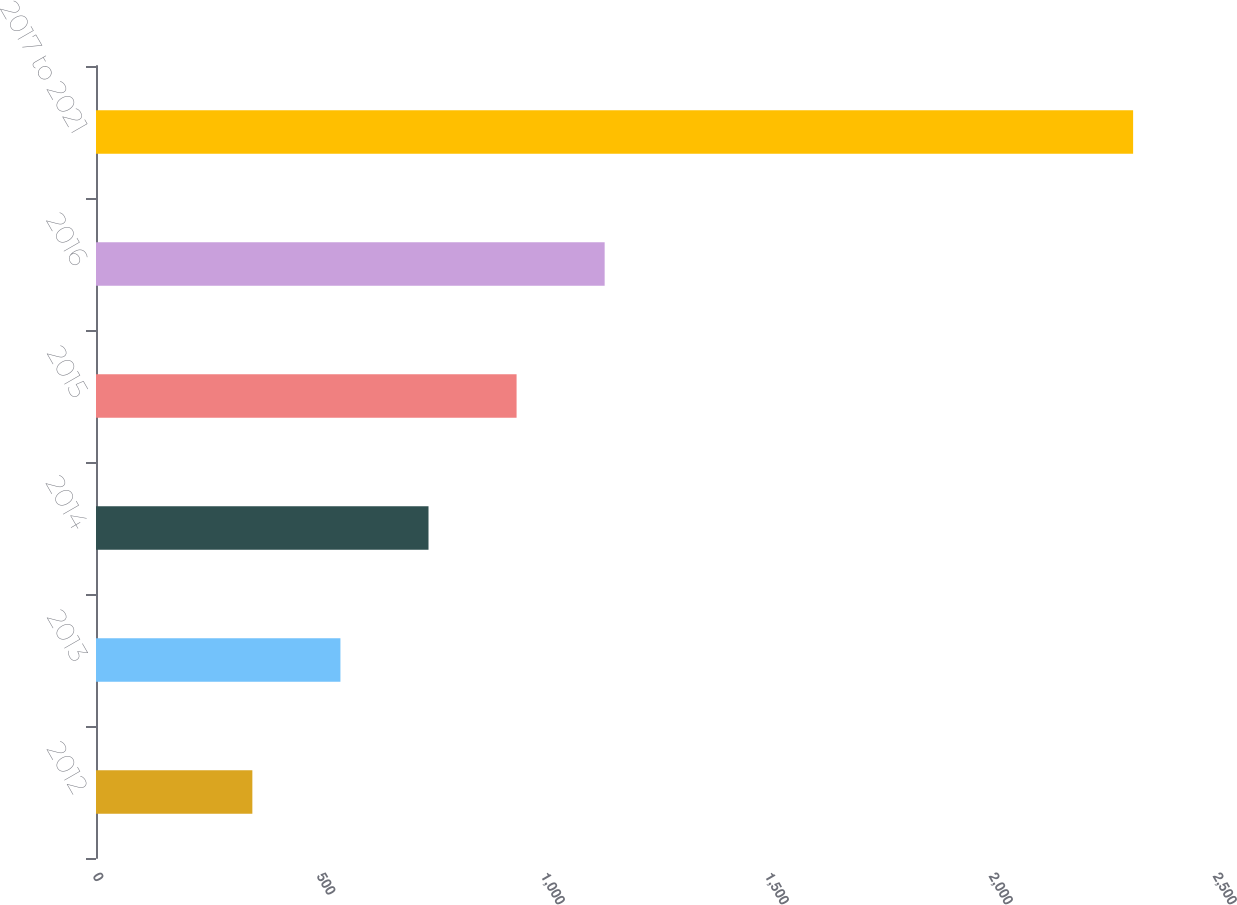Convert chart to OTSL. <chart><loc_0><loc_0><loc_500><loc_500><bar_chart><fcel>2012<fcel>2013<fcel>2014<fcel>2015<fcel>2016<fcel>2017 to 2021<nl><fcel>349<fcel>545.6<fcel>742.2<fcel>938.8<fcel>1135.4<fcel>2315<nl></chart> 